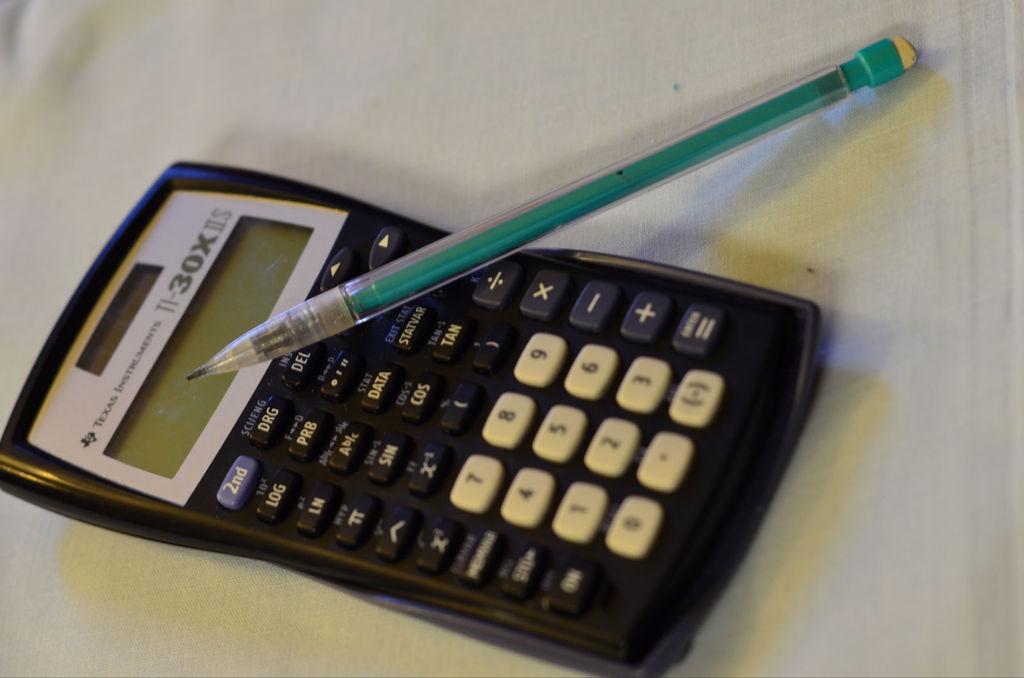Can you describe this image briefly? In this image we can see a calculator and a pencil placed on a table 